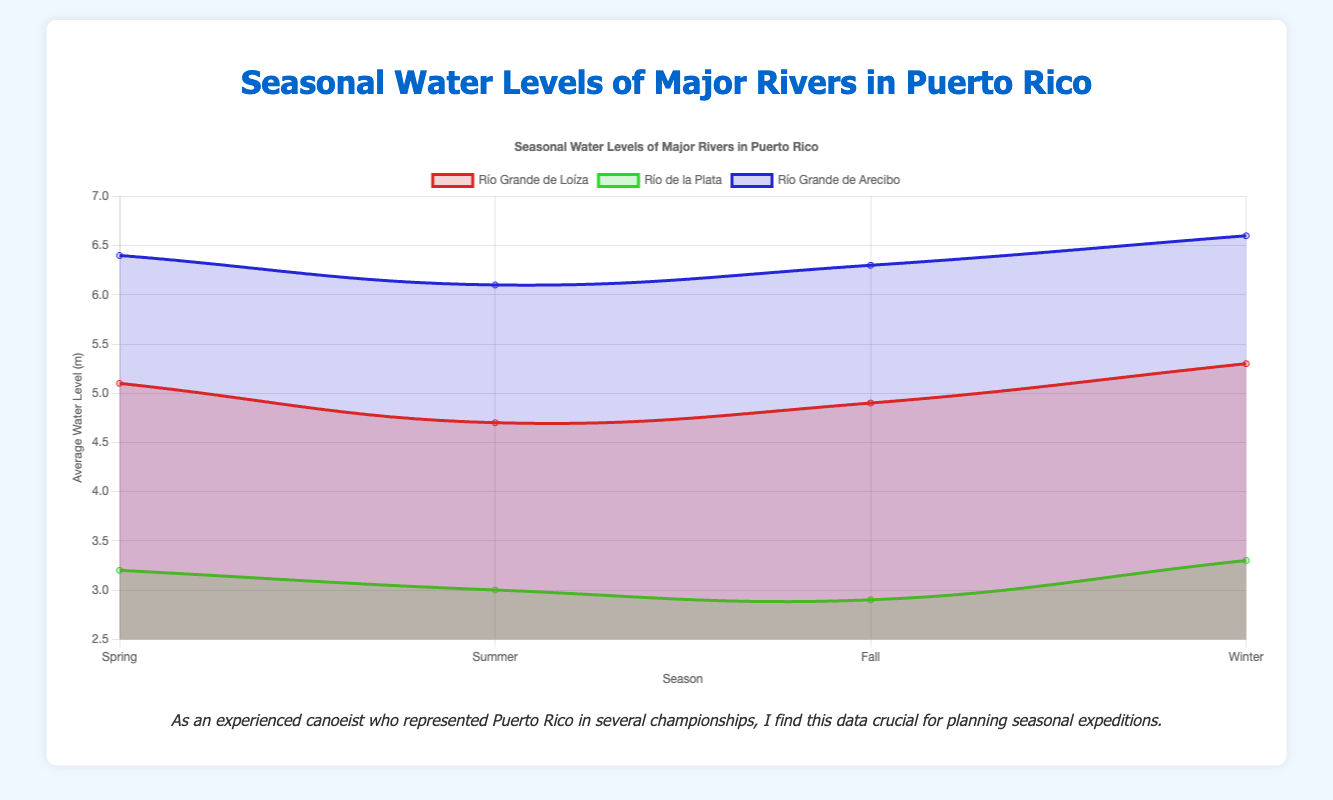Which river has the highest average water level during spring? By looking at the figure, identify which line representing a river has the highest point in the spring section of the x-axis.
Answer: Río Grande de Arecibo What is the overall seasonal pattern of water levels for Río de la Plata? Observe the Río de la Plata line and its trend across spring, summer, fall, and winter, noting any increases or decreases.
Answer: Decreases in summer and fall, increases in spring and winter How does the average water level of Río Grande de Loíza in winter compare to its level in summer? Compare the points for Río Grande de Loíza during winter and summer on the y-axis.
Answer: Higher in winter Which season shows the greatest variation in water levels among all rivers? Look at the spread of points for all rivers within each season and identify the season with the largest difference between the highest and lowest points.
Answer: Winter What is the combined average water level of Río Grande de Loíza for spring and fall? Add the average water levels of Río Grande de Loíza for spring and fall and then compute the average of these two values. (5.1 + 4.9) / 2 = 5.0
Answer: 5.0 How do the water levels of Río Grande de Arecibo in summer and winter differ? Compare the data points for Río Grande de Arecibo's summer and winter values; note the difference between them.
Answer: Higher in winter Between which two seasons does Río Grande de Arecibo show the smallest change in water levels? Examine the y-axis positions for Río Grande de Arecibo's seasonal points and identify which two consecutive seasons have the least difference in their water levels.
Answer: Spring and Fall What is the visual trend of Río de la Plata's water levels throughout the year? Note the general movement (upwards or downwards) by following the Río de la Plata line across the x-axis from spring to winter.
Answer: V-shape (Decreases and then increases) 